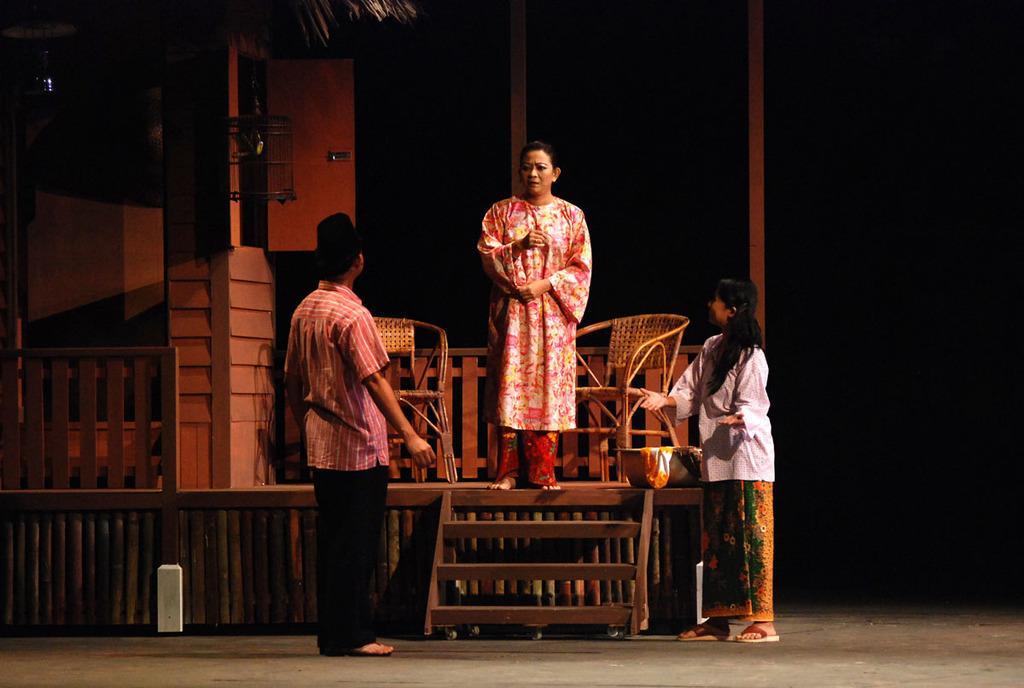Please provide a concise description of this image. In the middle of this image I can see a woman standing on the stage. In front of her I can see a man and a woman are standing on the ground and looking at her. At the back of this woman there are two empty chairs. On the left side, I can see a pillar and railing. The background is in black color. 